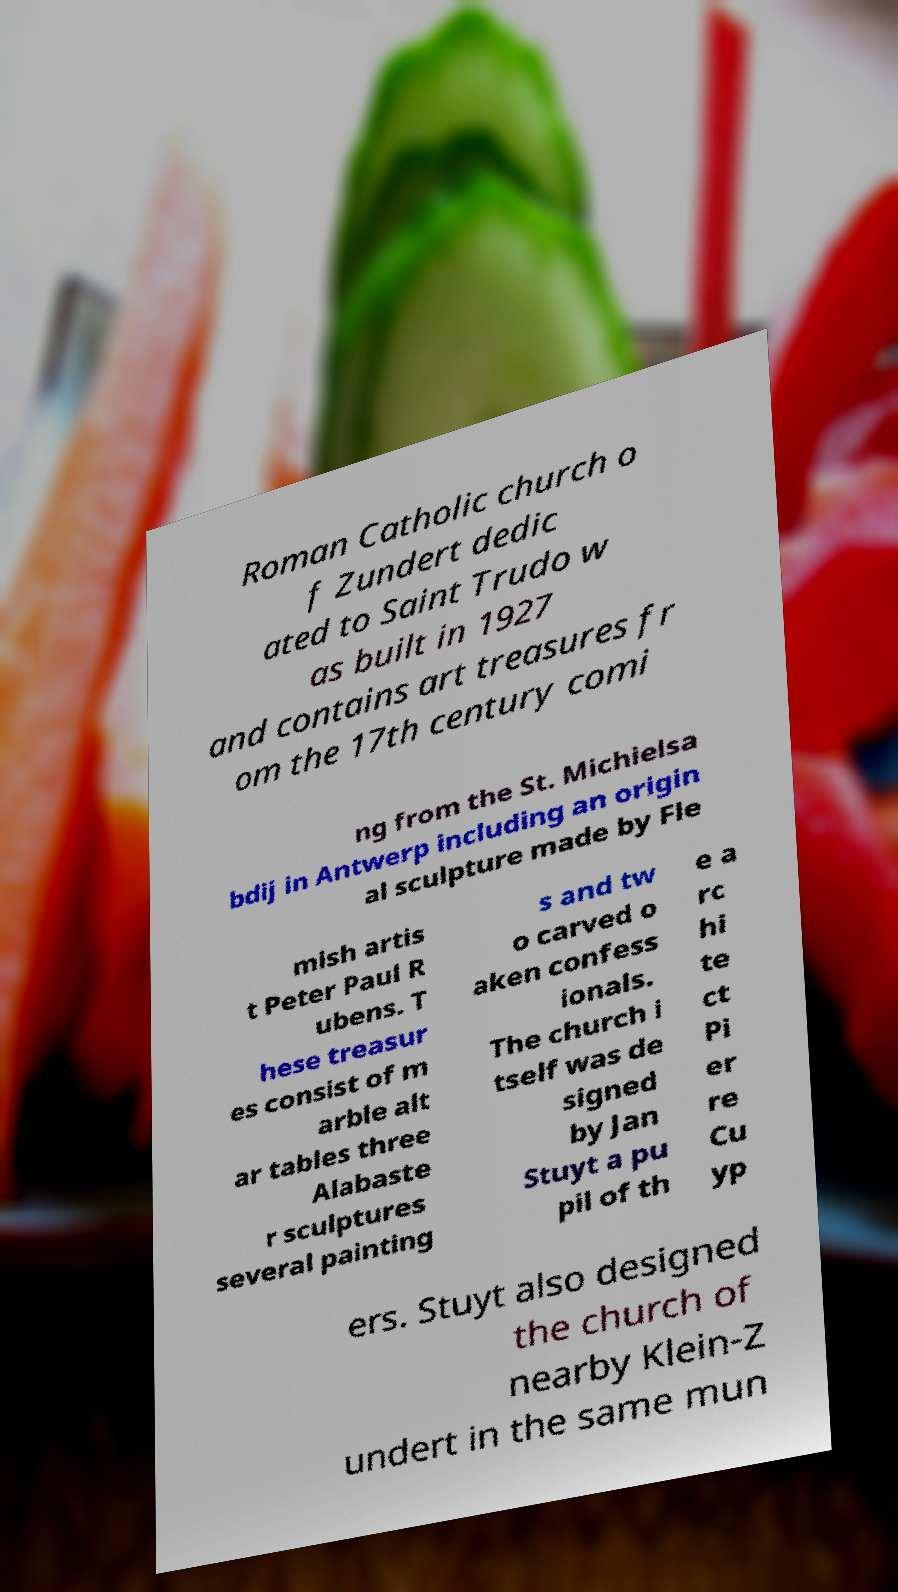Could you assist in decoding the text presented in this image and type it out clearly? Roman Catholic church o f Zundert dedic ated to Saint Trudo w as built in 1927 and contains art treasures fr om the 17th century comi ng from the St. Michielsa bdij in Antwerp including an origin al sculpture made by Fle mish artis t Peter Paul R ubens. T hese treasur es consist of m arble alt ar tables three Alabaste r sculptures several painting s and tw o carved o aken confess ionals. The church i tself was de signed by Jan Stuyt a pu pil of th e a rc hi te ct Pi er re Cu yp ers. Stuyt also designed the church of nearby Klein-Z undert in the same mun 